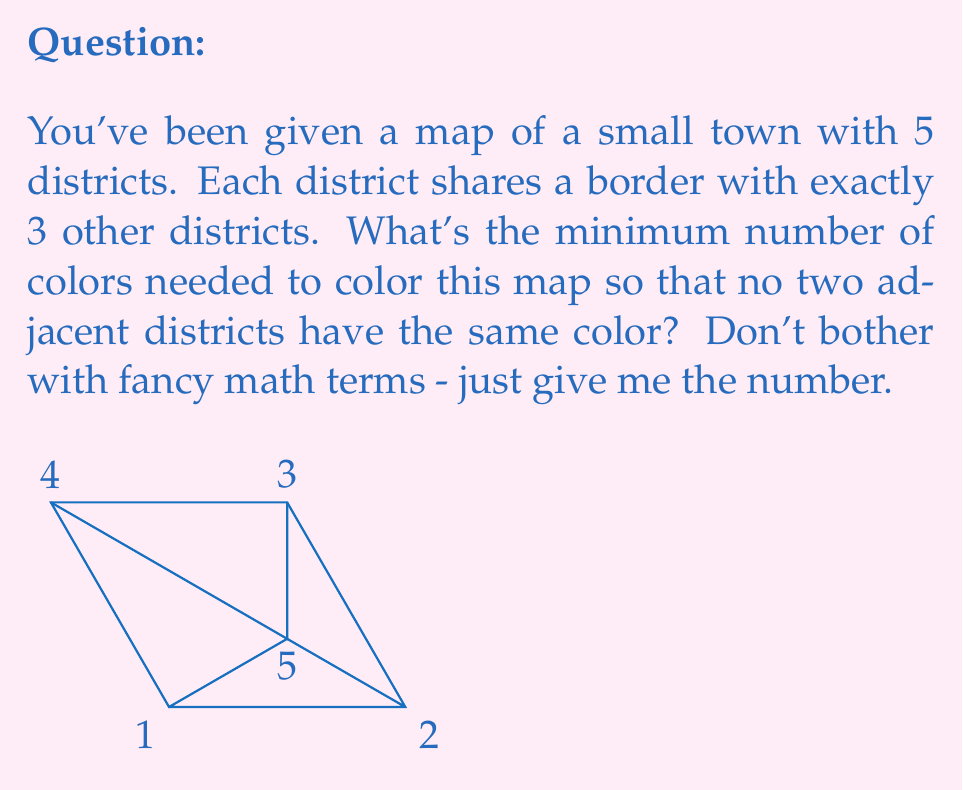What is the answer to this math problem? Alright, let's break this down without any fancy jargon:

1) First, we need to understand what the question is asking. We've got 5 areas, and each one touches 3 others. We need to color them so that no two touching areas have the same color.

2) Now, let's think about it step by step:
   - If we start coloring with one color, we can only use it once because each area touches all the others except one.
   - So, we use our second color for another area.
   - Then our third color for another area.
   - At this point, we've colored 3 areas.

3) For the 4th area, we might be able to use one of the first three colors, depending on how we arranged them.

4) For the last area, we definitely can use one of the first three colors, because it only touches 3 other areas, and we have 3 colors to choose from.

5) So, we don't need more than 3 colors to do the job.

6) Could we do it with fewer? Well, if we only had 2 colors, we'd run into trouble real quick. As soon as we color two areas, the third one touching both of them would need a third color.

So, 3 is the magic number here. It's enough to do the job, and we can't get away with less.
Answer: 3 colors 